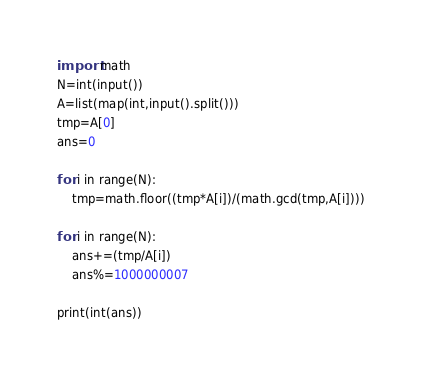<code> <loc_0><loc_0><loc_500><loc_500><_Python_>import math
N=int(input())
A=list(map(int,input().split()))
tmp=A[0]
ans=0

for i in range(N):
    tmp=math.floor((tmp*A[i])/(math.gcd(tmp,A[i])))

for i in range(N):
    ans+=(tmp/A[i])
    ans%=1000000007
    
print(int(ans))</code> 